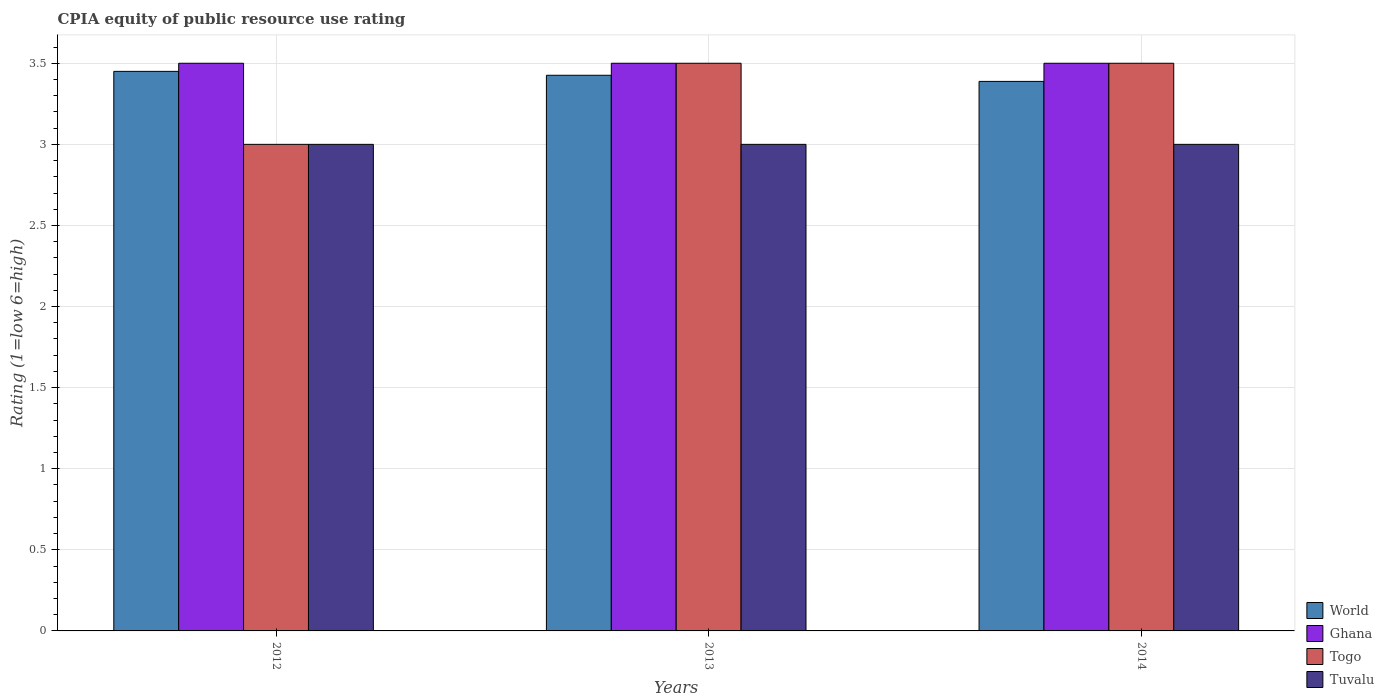Are the number of bars on each tick of the X-axis equal?
Your response must be concise. Yes. How many bars are there on the 2nd tick from the right?
Ensure brevity in your answer.  4. What is the CPIA rating in Togo in 2014?
Keep it short and to the point. 3.5. Across all years, what is the minimum CPIA rating in Togo?
Provide a short and direct response. 3. In which year was the CPIA rating in Ghana maximum?
Your response must be concise. 2012. What is the total CPIA rating in Ghana in the graph?
Keep it short and to the point. 10.5. What is the difference between the CPIA rating in Tuvalu in 2013 and that in 2014?
Your answer should be compact. 0. What is the average CPIA rating in World per year?
Provide a succinct answer. 3.42. In the year 2014, what is the difference between the CPIA rating in Togo and CPIA rating in Tuvalu?
Keep it short and to the point. 0.5. In how many years, is the CPIA rating in Togo greater than 2?
Provide a succinct answer. 3. What is the ratio of the CPIA rating in Togo in 2013 to that in 2014?
Provide a short and direct response. 1. Is the difference between the CPIA rating in Togo in 2013 and 2014 greater than the difference between the CPIA rating in Tuvalu in 2013 and 2014?
Your answer should be very brief. No. What is the difference between the highest and the second highest CPIA rating in World?
Provide a succinct answer. 0.02. What is the difference between the highest and the lowest CPIA rating in Tuvalu?
Your answer should be very brief. 0. Is the sum of the CPIA rating in Tuvalu in 2012 and 2014 greater than the maximum CPIA rating in Ghana across all years?
Provide a short and direct response. Yes. What does the 2nd bar from the left in 2013 represents?
Provide a short and direct response. Ghana. What does the 4th bar from the right in 2012 represents?
Make the answer very short. World. Is it the case that in every year, the sum of the CPIA rating in World and CPIA rating in Togo is greater than the CPIA rating in Tuvalu?
Make the answer very short. Yes. What is the difference between two consecutive major ticks on the Y-axis?
Provide a succinct answer. 0.5. Does the graph contain any zero values?
Your answer should be very brief. No. Where does the legend appear in the graph?
Keep it short and to the point. Bottom right. How many legend labels are there?
Offer a very short reply. 4. What is the title of the graph?
Provide a succinct answer. CPIA equity of public resource use rating. What is the label or title of the X-axis?
Make the answer very short. Years. What is the label or title of the Y-axis?
Give a very brief answer. Rating (1=low 6=high). What is the Rating (1=low 6=high) in World in 2012?
Provide a short and direct response. 3.45. What is the Rating (1=low 6=high) of Ghana in 2012?
Provide a short and direct response. 3.5. What is the Rating (1=low 6=high) of Togo in 2012?
Your response must be concise. 3. What is the Rating (1=low 6=high) of World in 2013?
Your answer should be very brief. 3.43. What is the Rating (1=low 6=high) of Ghana in 2013?
Make the answer very short. 3.5. What is the Rating (1=low 6=high) in World in 2014?
Your answer should be compact. 3.39. What is the Rating (1=low 6=high) of Togo in 2014?
Your answer should be compact. 3.5. What is the Rating (1=low 6=high) in Tuvalu in 2014?
Provide a short and direct response. 3. Across all years, what is the maximum Rating (1=low 6=high) of World?
Provide a succinct answer. 3.45. Across all years, what is the maximum Rating (1=low 6=high) of Togo?
Your answer should be very brief. 3.5. Across all years, what is the maximum Rating (1=low 6=high) in Tuvalu?
Make the answer very short. 3. Across all years, what is the minimum Rating (1=low 6=high) of World?
Make the answer very short. 3.39. Across all years, what is the minimum Rating (1=low 6=high) in Togo?
Your response must be concise. 3. What is the total Rating (1=low 6=high) of World in the graph?
Give a very brief answer. 10.26. What is the total Rating (1=low 6=high) of Ghana in the graph?
Ensure brevity in your answer.  10.5. What is the difference between the Rating (1=low 6=high) of World in 2012 and that in 2013?
Give a very brief answer. 0.02. What is the difference between the Rating (1=low 6=high) of Togo in 2012 and that in 2013?
Your answer should be very brief. -0.5. What is the difference between the Rating (1=low 6=high) in Tuvalu in 2012 and that in 2013?
Your answer should be compact. 0. What is the difference between the Rating (1=low 6=high) of World in 2012 and that in 2014?
Your response must be concise. 0.06. What is the difference between the Rating (1=low 6=high) of Ghana in 2012 and that in 2014?
Offer a terse response. 0. What is the difference between the Rating (1=low 6=high) in Togo in 2012 and that in 2014?
Keep it short and to the point. -0.5. What is the difference between the Rating (1=low 6=high) of Tuvalu in 2012 and that in 2014?
Offer a terse response. 0. What is the difference between the Rating (1=low 6=high) in World in 2013 and that in 2014?
Your response must be concise. 0.04. What is the difference between the Rating (1=low 6=high) in Ghana in 2013 and that in 2014?
Provide a short and direct response. 0. What is the difference between the Rating (1=low 6=high) in Togo in 2013 and that in 2014?
Keep it short and to the point. 0. What is the difference between the Rating (1=low 6=high) of World in 2012 and the Rating (1=low 6=high) of Tuvalu in 2013?
Your answer should be compact. 0.45. What is the difference between the Rating (1=low 6=high) of Ghana in 2012 and the Rating (1=low 6=high) of Togo in 2013?
Ensure brevity in your answer.  0. What is the difference between the Rating (1=low 6=high) in Ghana in 2012 and the Rating (1=low 6=high) in Tuvalu in 2013?
Give a very brief answer. 0.5. What is the difference between the Rating (1=low 6=high) in World in 2012 and the Rating (1=low 6=high) in Ghana in 2014?
Your answer should be very brief. -0.05. What is the difference between the Rating (1=low 6=high) in World in 2012 and the Rating (1=low 6=high) in Tuvalu in 2014?
Ensure brevity in your answer.  0.45. What is the difference between the Rating (1=low 6=high) in Ghana in 2012 and the Rating (1=low 6=high) in Tuvalu in 2014?
Keep it short and to the point. 0.5. What is the difference between the Rating (1=low 6=high) in Togo in 2012 and the Rating (1=low 6=high) in Tuvalu in 2014?
Your answer should be very brief. 0. What is the difference between the Rating (1=low 6=high) in World in 2013 and the Rating (1=low 6=high) in Ghana in 2014?
Provide a succinct answer. -0.07. What is the difference between the Rating (1=low 6=high) of World in 2013 and the Rating (1=low 6=high) of Togo in 2014?
Your response must be concise. -0.07. What is the difference between the Rating (1=low 6=high) of World in 2013 and the Rating (1=low 6=high) of Tuvalu in 2014?
Offer a terse response. 0.43. What is the difference between the Rating (1=low 6=high) of Ghana in 2013 and the Rating (1=low 6=high) of Togo in 2014?
Your answer should be compact. 0. What is the difference between the Rating (1=low 6=high) in Ghana in 2013 and the Rating (1=low 6=high) in Tuvalu in 2014?
Offer a very short reply. 0.5. What is the average Rating (1=low 6=high) of World per year?
Your answer should be very brief. 3.42. What is the average Rating (1=low 6=high) of Ghana per year?
Keep it short and to the point. 3.5. What is the average Rating (1=low 6=high) in Togo per year?
Offer a very short reply. 3.33. What is the average Rating (1=low 6=high) of Tuvalu per year?
Give a very brief answer. 3. In the year 2012, what is the difference between the Rating (1=low 6=high) in World and Rating (1=low 6=high) in Ghana?
Offer a very short reply. -0.05. In the year 2012, what is the difference between the Rating (1=low 6=high) in World and Rating (1=low 6=high) in Togo?
Your answer should be compact. 0.45. In the year 2012, what is the difference between the Rating (1=low 6=high) in World and Rating (1=low 6=high) in Tuvalu?
Provide a succinct answer. 0.45. In the year 2012, what is the difference between the Rating (1=low 6=high) of Ghana and Rating (1=low 6=high) of Togo?
Your answer should be very brief. 0.5. In the year 2012, what is the difference between the Rating (1=low 6=high) of Togo and Rating (1=low 6=high) of Tuvalu?
Give a very brief answer. 0. In the year 2013, what is the difference between the Rating (1=low 6=high) in World and Rating (1=low 6=high) in Ghana?
Ensure brevity in your answer.  -0.07. In the year 2013, what is the difference between the Rating (1=low 6=high) in World and Rating (1=low 6=high) in Togo?
Provide a succinct answer. -0.07. In the year 2013, what is the difference between the Rating (1=low 6=high) in World and Rating (1=low 6=high) in Tuvalu?
Your response must be concise. 0.43. In the year 2013, what is the difference between the Rating (1=low 6=high) in Ghana and Rating (1=low 6=high) in Tuvalu?
Make the answer very short. 0.5. In the year 2013, what is the difference between the Rating (1=low 6=high) in Togo and Rating (1=low 6=high) in Tuvalu?
Offer a terse response. 0.5. In the year 2014, what is the difference between the Rating (1=low 6=high) of World and Rating (1=low 6=high) of Ghana?
Your answer should be very brief. -0.11. In the year 2014, what is the difference between the Rating (1=low 6=high) in World and Rating (1=low 6=high) in Togo?
Keep it short and to the point. -0.11. In the year 2014, what is the difference between the Rating (1=low 6=high) of World and Rating (1=low 6=high) of Tuvalu?
Provide a succinct answer. 0.39. In the year 2014, what is the difference between the Rating (1=low 6=high) in Ghana and Rating (1=low 6=high) in Tuvalu?
Give a very brief answer. 0.5. What is the ratio of the Rating (1=low 6=high) in World in 2012 to that in 2013?
Provide a short and direct response. 1.01. What is the ratio of the Rating (1=low 6=high) of Ghana in 2012 to that in 2013?
Your response must be concise. 1. What is the ratio of the Rating (1=low 6=high) in Tuvalu in 2012 to that in 2013?
Your answer should be compact. 1. What is the ratio of the Rating (1=low 6=high) of World in 2012 to that in 2014?
Ensure brevity in your answer.  1.02. What is the ratio of the Rating (1=low 6=high) of Togo in 2012 to that in 2014?
Ensure brevity in your answer.  0.86. What is the ratio of the Rating (1=low 6=high) of Tuvalu in 2012 to that in 2014?
Your response must be concise. 1. What is the ratio of the Rating (1=low 6=high) in World in 2013 to that in 2014?
Offer a very short reply. 1.01. What is the ratio of the Rating (1=low 6=high) in Ghana in 2013 to that in 2014?
Your response must be concise. 1. What is the ratio of the Rating (1=low 6=high) of Tuvalu in 2013 to that in 2014?
Give a very brief answer. 1. What is the difference between the highest and the second highest Rating (1=low 6=high) of World?
Give a very brief answer. 0.02. What is the difference between the highest and the second highest Rating (1=low 6=high) in Ghana?
Provide a short and direct response. 0. What is the difference between the highest and the lowest Rating (1=low 6=high) of World?
Your answer should be compact. 0.06. What is the difference between the highest and the lowest Rating (1=low 6=high) in Ghana?
Offer a very short reply. 0. What is the difference between the highest and the lowest Rating (1=low 6=high) in Togo?
Ensure brevity in your answer.  0.5. What is the difference between the highest and the lowest Rating (1=low 6=high) in Tuvalu?
Give a very brief answer. 0. 